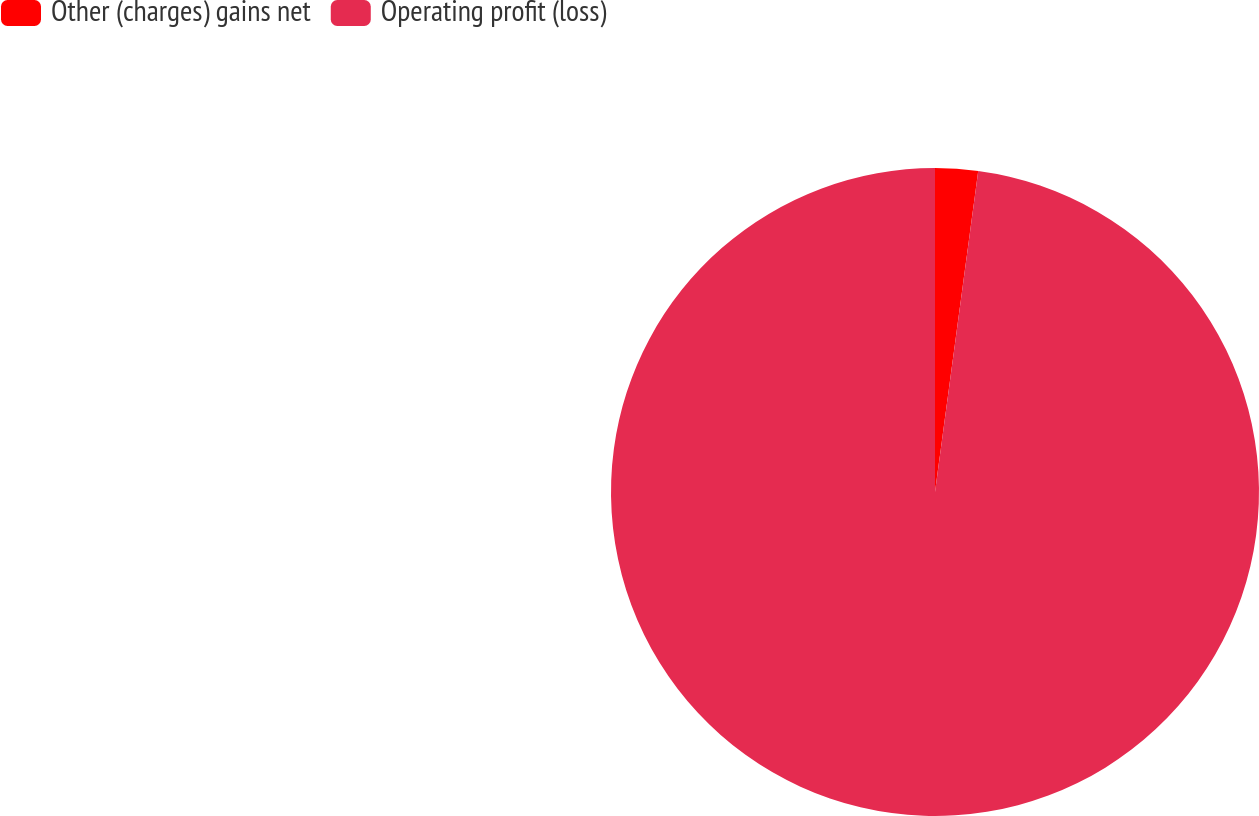Convert chart. <chart><loc_0><loc_0><loc_500><loc_500><pie_chart><fcel>Other (charges) gains net<fcel>Operating profit (loss)<nl><fcel>2.13%<fcel>97.87%<nl></chart> 